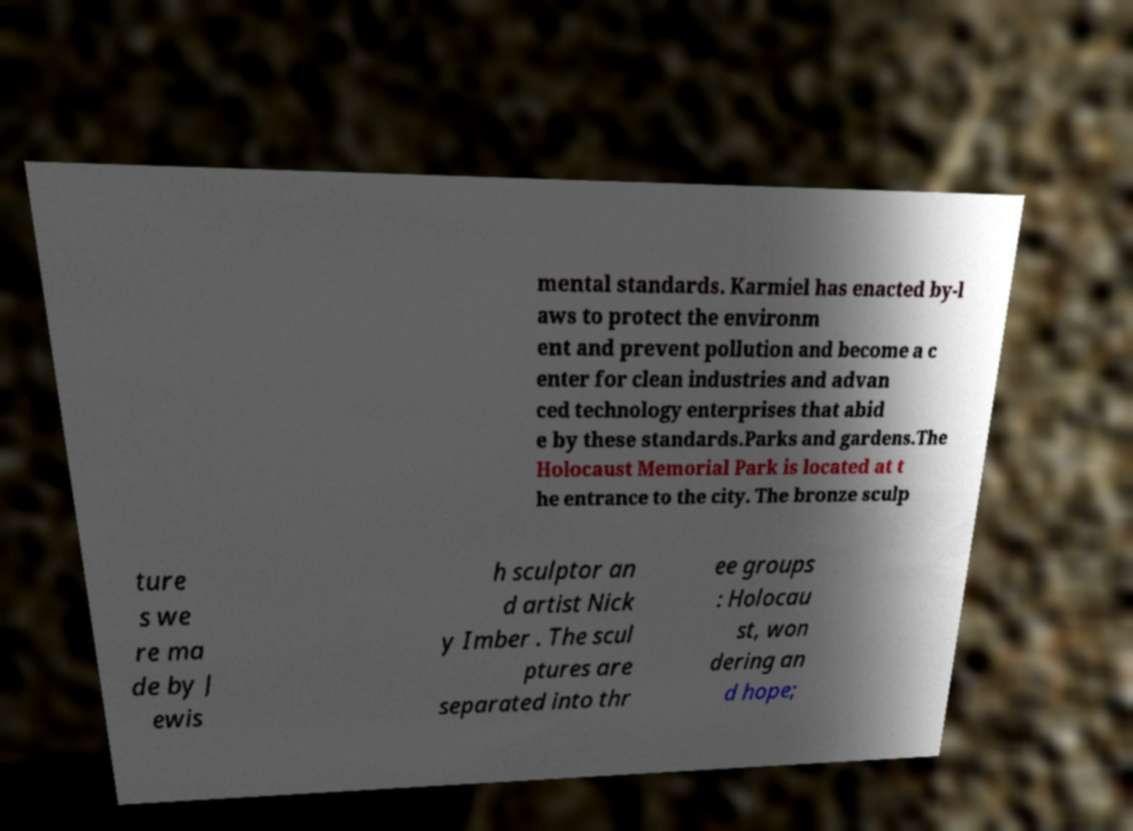Can you accurately transcribe the text from the provided image for me? mental standards. Karmiel has enacted by-l aws to protect the environm ent and prevent pollution and become a c enter for clean industries and advan ced technology enterprises that abid e by these standards.Parks and gardens.The Holocaust Memorial Park is located at t he entrance to the city. The bronze sculp ture s we re ma de by J ewis h sculptor an d artist Nick y Imber . The scul ptures are separated into thr ee groups : Holocau st, won dering an d hope; 